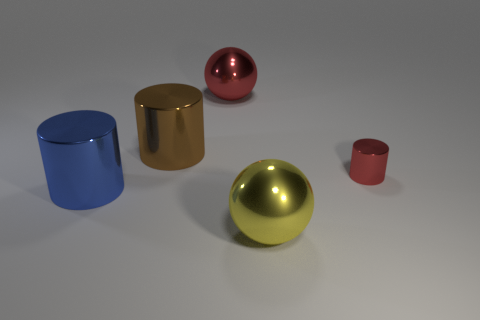What is the shape of the big brown metal thing?
Your answer should be compact. Cylinder. Are there an equal number of large blue metal cylinders behind the large brown shiny thing and big metallic cylinders behind the small red metallic cylinder?
Ensure brevity in your answer.  No. Are there any large spheres left of the metallic sphere in front of the red object that is left of the tiny red shiny cylinder?
Give a very brief answer. Yes. Is the size of the blue metal object the same as the red cylinder?
Provide a short and direct response. No. There is a big metal sphere that is behind the yellow metal sphere to the right of the big cylinder that is to the right of the big blue cylinder; what is its color?
Make the answer very short. Red. What number of spheres have the same color as the tiny metal cylinder?
Provide a short and direct response. 1. What number of big things are either red metal cylinders or shiny balls?
Your answer should be compact. 2. Is there a large brown object of the same shape as the small red shiny thing?
Provide a succinct answer. Yes. Do the brown metallic object and the small red shiny thing have the same shape?
Give a very brief answer. Yes. There is a cylinder that is on the right side of the large cylinder that is behind the large blue cylinder; what is its color?
Your response must be concise. Red. 